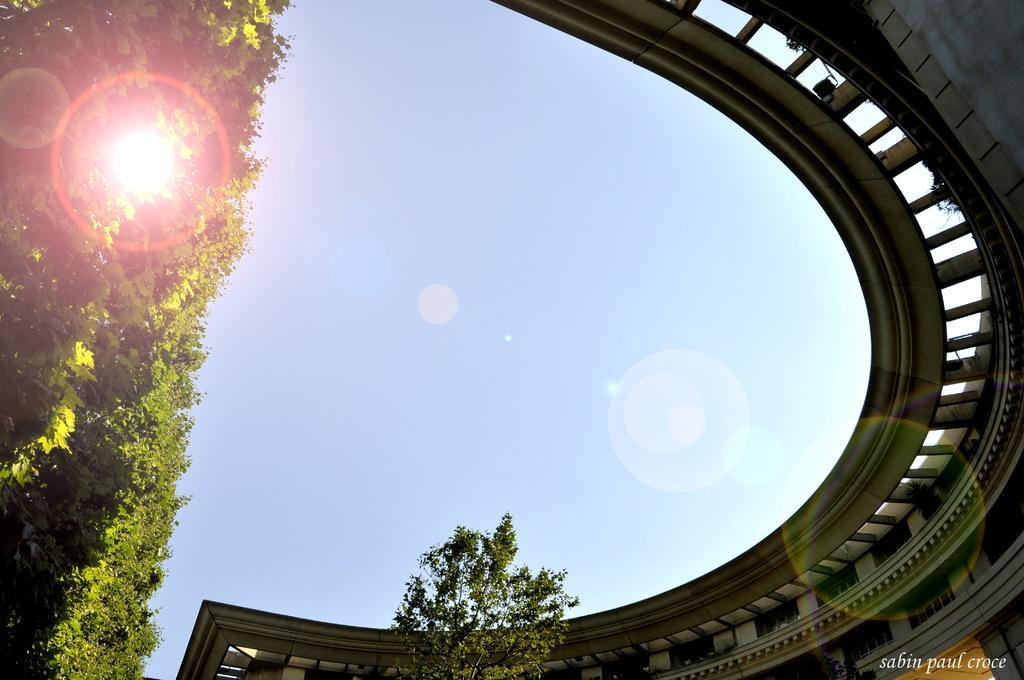Could you give a brief overview of what you see in this image? In this image I can see the blue color sky. To the right I can see the building and to the left there are many trees. I can also see the watermark to the side. 